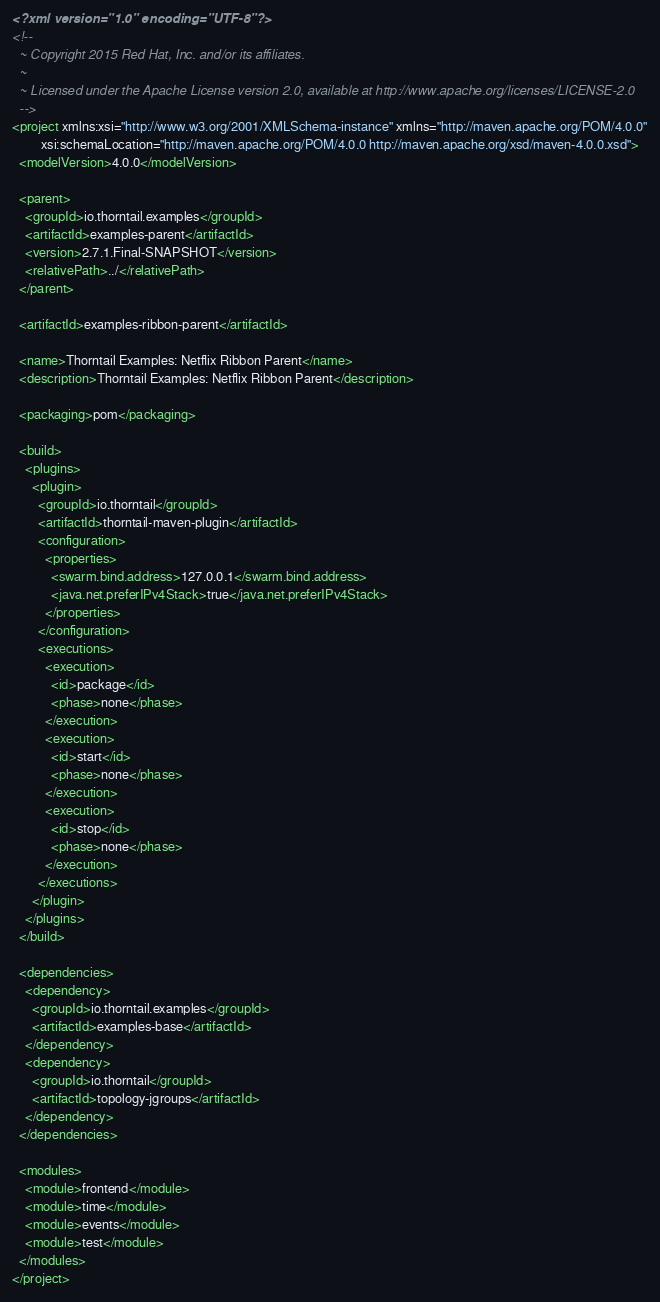<code> <loc_0><loc_0><loc_500><loc_500><_XML_><?xml version="1.0" encoding="UTF-8"?>
<!--
  ~ Copyright 2015 Red Hat, Inc. and/or its affiliates.
  ~
  ~ Licensed under the Apache License version 2.0, available at http://www.apache.org/licenses/LICENSE-2.0
  -->
<project xmlns:xsi="http://www.w3.org/2001/XMLSchema-instance" xmlns="http://maven.apache.org/POM/4.0.0"
         xsi:schemaLocation="http://maven.apache.org/POM/4.0.0 http://maven.apache.org/xsd/maven-4.0.0.xsd">
  <modelVersion>4.0.0</modelVersion>

  <parent>
    <groupId>io.thorntail.examples</groupId>
    <artifactId>examples-parent</artifactId>
    <version>2.7.1.Final-SNAPSHOT</version>
    <relativePath>../</relativePath>
  </parent>

  <artifactId>examples-ribbon-parent</artifactId>

  <name>Thorntail Examples: Netflix Ribbon Parent</name>
  <description>Thorntail Examples: Netflix Ribbon Parent</description>

  <packaging>pom</packaging>

  <build>
    <plugins>
      <plugin>
        <groupId>io.thorntail</groupId>
        <artifactId>thorntail-maven-plugin</artifactId>
        <configuration>
          <properties>
            <swarm.bind.address>127.0.0.1</swarm.bind.address>
            <java.net.preferIPv4Stack>true</java.net.preferIPv4Stack>
          </properties>
        </configuration>
        <executions>
          <execution>
            <id>package</id>
            <phase>none</phase>
          </execution>
          <execution>
            <id>start</id>
            <phase>none</phase>
          </execution>
          <execution>
            <id>stop</id>
            <phase>none</phase>
          </execution>
        </executions>
      </plugin>
    </plugins>
  </build>

  <dependencies>
    <dependency>
      <groupId>io.thorntail.examples</groupId>
      <artifactId>examples-base</artifactId>
    </dependency>
    <dependency>
      <groupId>io.thorntail</groupId>
      <artifactId>topology-jgroups</artifactId>
    </dependency>
  </dependencies>

  <modules>
    <module>frontend</module>
    <module>time</module>
    <module>events</module>
    <module>test</module>
  </modules>
</project>
</code> 